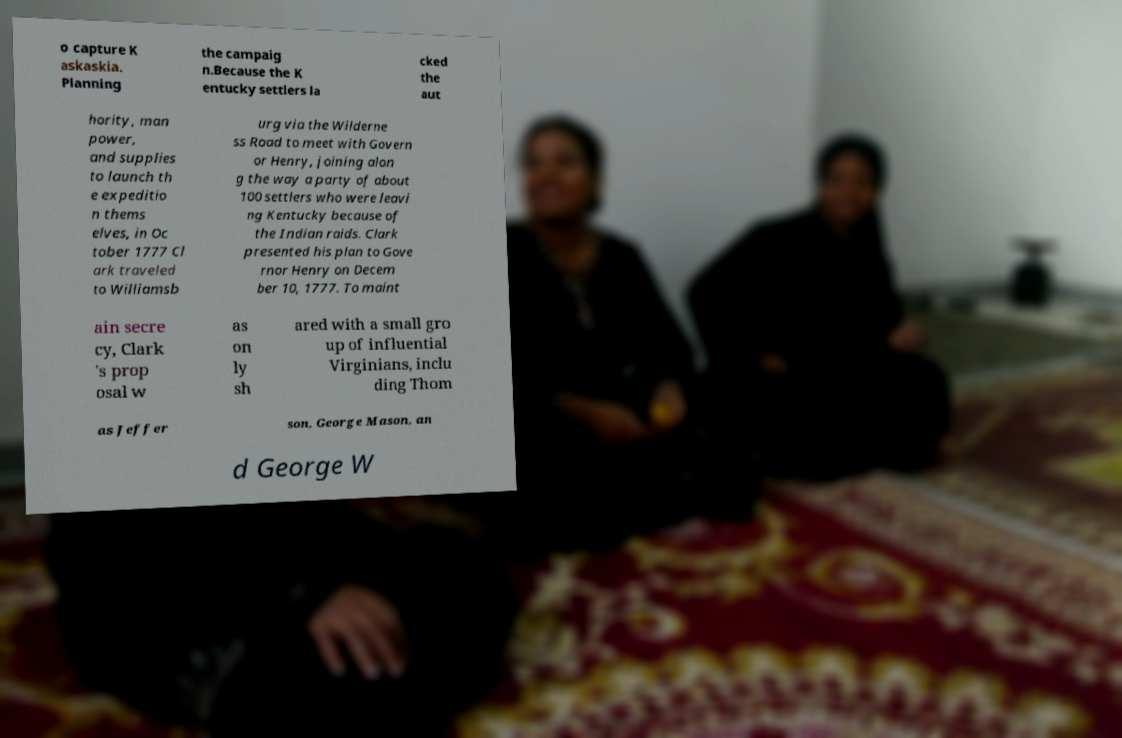Could you extract and type out the text from this image? o capture K askaskia. Planning the campaig n.Because the K entucky settlers la cked the aut hority, man power, and supplies to launch th e expeditio n thems elves, in Oc tober 1777 Cl ark traveled to Williamsb urg via the Wilderne ss Road to meet with Govern or Henry, joining alon g the way a party of about 100 settlers who were leavi ng Kentucky because of the Indian raids. Clark presented his plan to Gove rnor Henry on Decem ber 10, 1777. To maint ain secre cy, Clark 's prop osal w as on ly sh ared with a small gro up of influential Virginians, inclu ding Thom as Jeffer son, George Mason, an d George W 